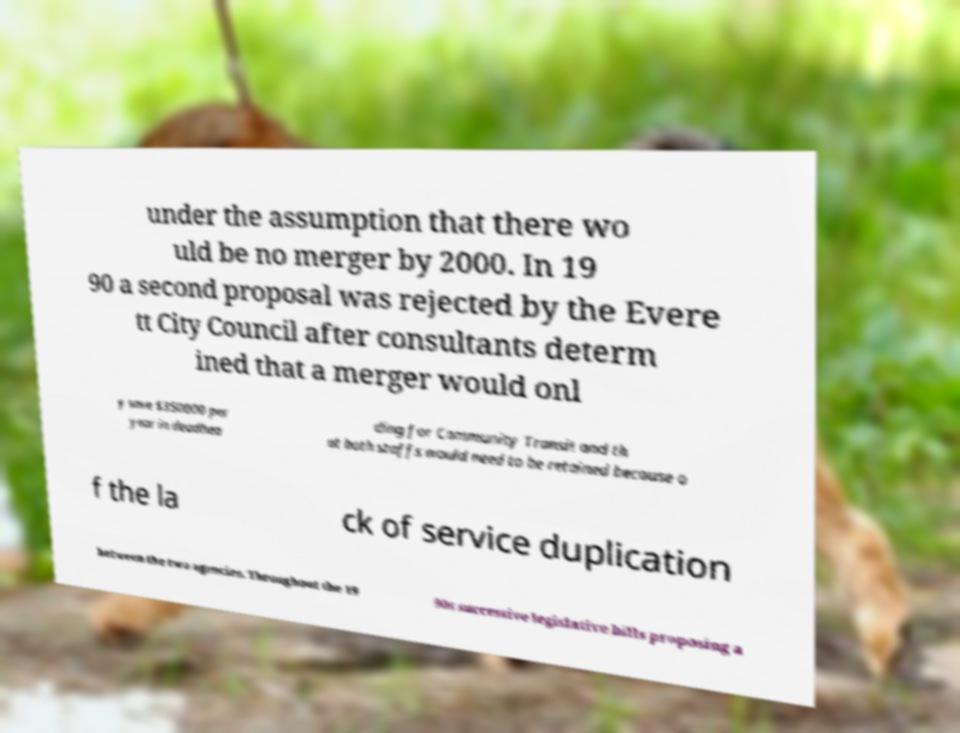There's text embedded in this image that I need extracted. Can you transcribe it verbatim? under the assumption that there wo uld be no merger by 2000. In 19 90 a second proposal was rejected by the Evere tt City Council after consultants determ ined that a merger would onl y save $350000 per year in deadhea ding for Community Transit and th at both staffs would need to be retained because o f the la ck of service duplication between the two agencies. Throughout the 19 90s successive legislative bills proposing a 